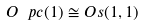Convert formula to latex. <formula><loc_0><loc_0><loc_500><loc_500>O _ { \ } p c ( 1 ) \cong O _ { \real } s ( 1 , 1 )</formula> 